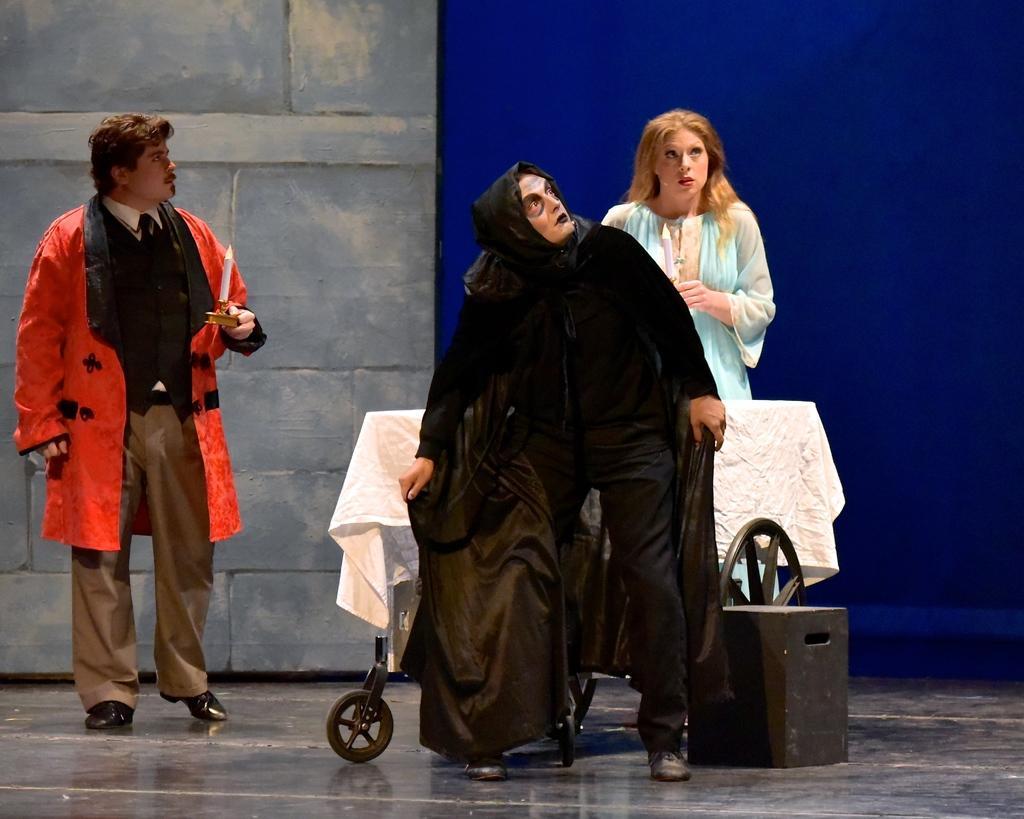How would you summarize this image in a sentence or two? In this image we can see a person wearing red coat is standing here and this person black dress is standing here. Here we can see a woman in the blue dress and the trolley here. In the background, we can see the stone wall and the blue color board. 